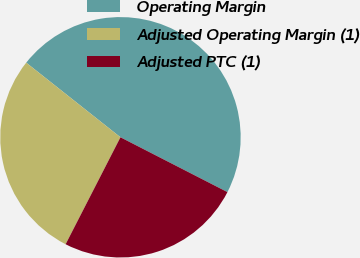Convert chart. <chart><loc_0><loc_0><loc_500><loc_500><pie_chart><fcel>Operating Margin<fcel>Adjusted Operating Margin (1)<fcel>Adjusted PTC (1)<nl><fcel>46.88%<fcel>28.12%<fcel>25.0%<nl></chart> 